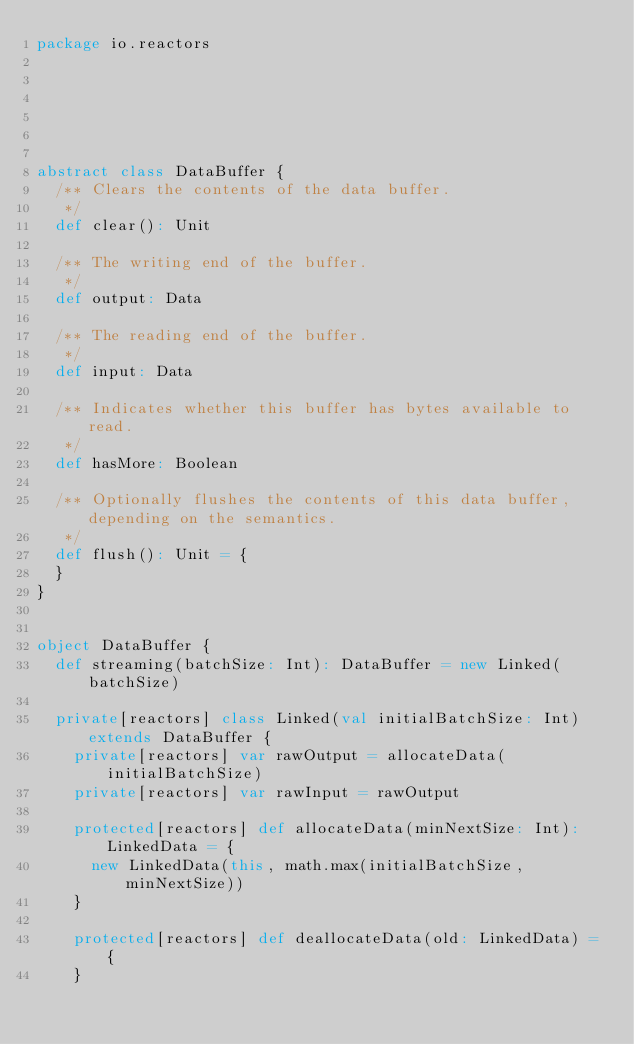<code> <loc_0><loc_0><loc_500><loc_500><_Scala_>package io.reactors






abstract class DataBuffer {
  /** Clears the contents of the data buffer.
   */
  def clear(): Unit

  /** The writing end of the buffer.
   */
  def output: Data

  /** The reading end of the buffer.
   */
  def input: Data

  /** Indicates whether this buffer has bytes available to read.
   */
  def hasMore: Boolean

  /** Optionally flushes the contents of this data buffer, depending on the semantics.
   */
  def flush(): Unit = {
  }
}


object DataBuffer {
  def streaming(batchSize: Int): DataBuffer = new Linked(batchSize)

  private[reactors] class Linked(val initialBatchSize: Int) extends DataBuffer {
    private[reactors] var rawOutput = allocateData(initialBatchSize)
    private[reactors] var rawInput = rawOutput

    protected[reactors] def allocateData(minNextSize: Int): LinkedData = {
      new LinkedData(this, math.max(initialBatchSize, minNextSize))
    }

    protected[reactors] def deallocateData(old: LinkedData) = {
    }
</code> 